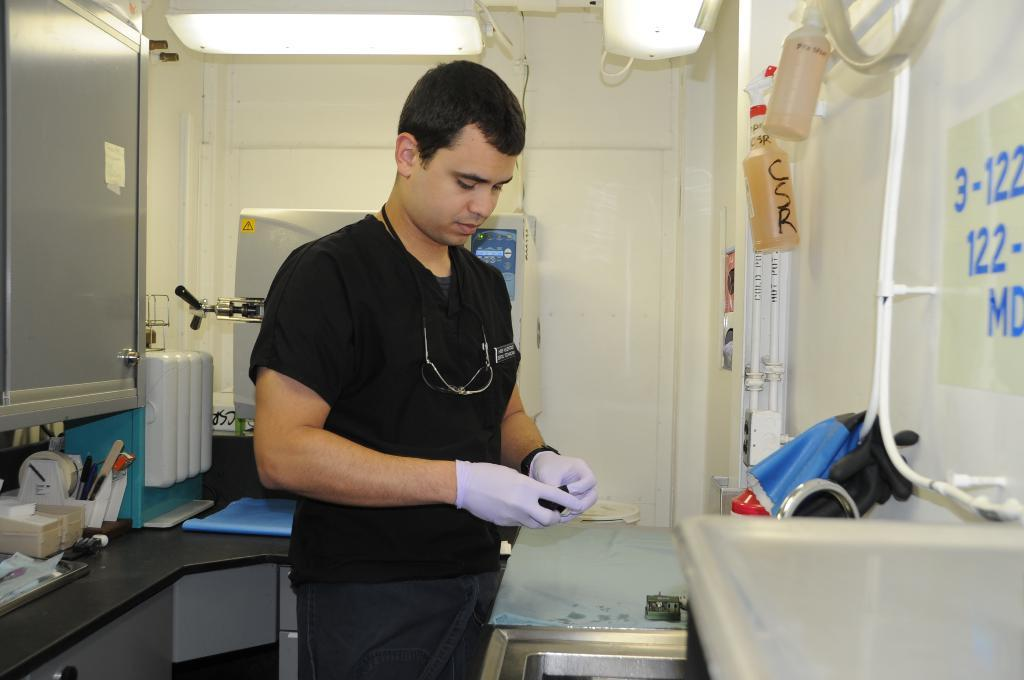What is the main subject of the image? There is a person standing in the image. What else can be seen in the image besides the person? There are objects on a table in the image. What is visible at the top of the image? There are lights visible at the top of the image. What type of nut is being cracked by the sun in the image? There is no nut or sun present in the image. Is the girl in the image playing with a toy? A: There is no girl or toy mentioned in the provided facts about the image. 